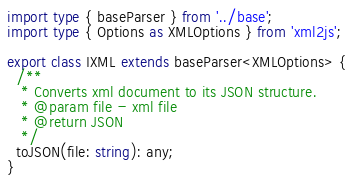<code> <loc_0><loc_0><loc_500><loc_500><_TypeScript_>import type { baseParser } from '../base';
import type { Options as XMLOptions } from 'xml2js';

export class IXML extends baseParser<XMLOptions> {
  /**
   * Converts xml document to its JSON structure.
   * @param file - xml file
   * @return JSON
   */
  toJSON(file: string): any;
}
</code> 